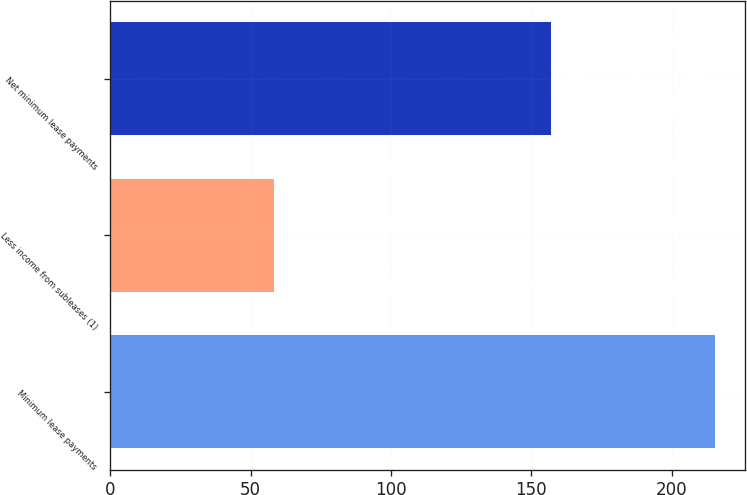Convert chart. <chart><loc_0><loc_0><loc_500><loc_500><bar_chart><fcel>Minimum lease payments<fcel>Less income from subleases (1)<fcel>Net minimum lease payments<nl><fcel>215.3<fcel>58.4<fcel>156.9<nl></chart> 